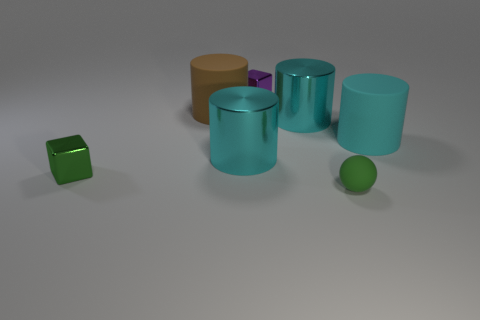Subtract all cyan cubes. How many cyan cylinders are left? 3 Subtract all large brown rubber cylinders. How many cylinders are left? 3 Subtract all brown cylinders. How many cylinders are left? 3 Subtract 1 cylinders. How many cylinders are left? 3 Add 2 yellow rubber balls. How many objects exist? 9 Subtract all cylinders. How many objects are left? 3 Subtract all blue cylinders. Subtract all red blocks. How many cylinders are left? 4 Add 6 tiny purple blocks. How many tiny purple blocks are left? 7 Add 3 large shiny cylinders. How many large shiny cylinders exist? 5 Subtract 1 green spheres. How many objects are left? 6 